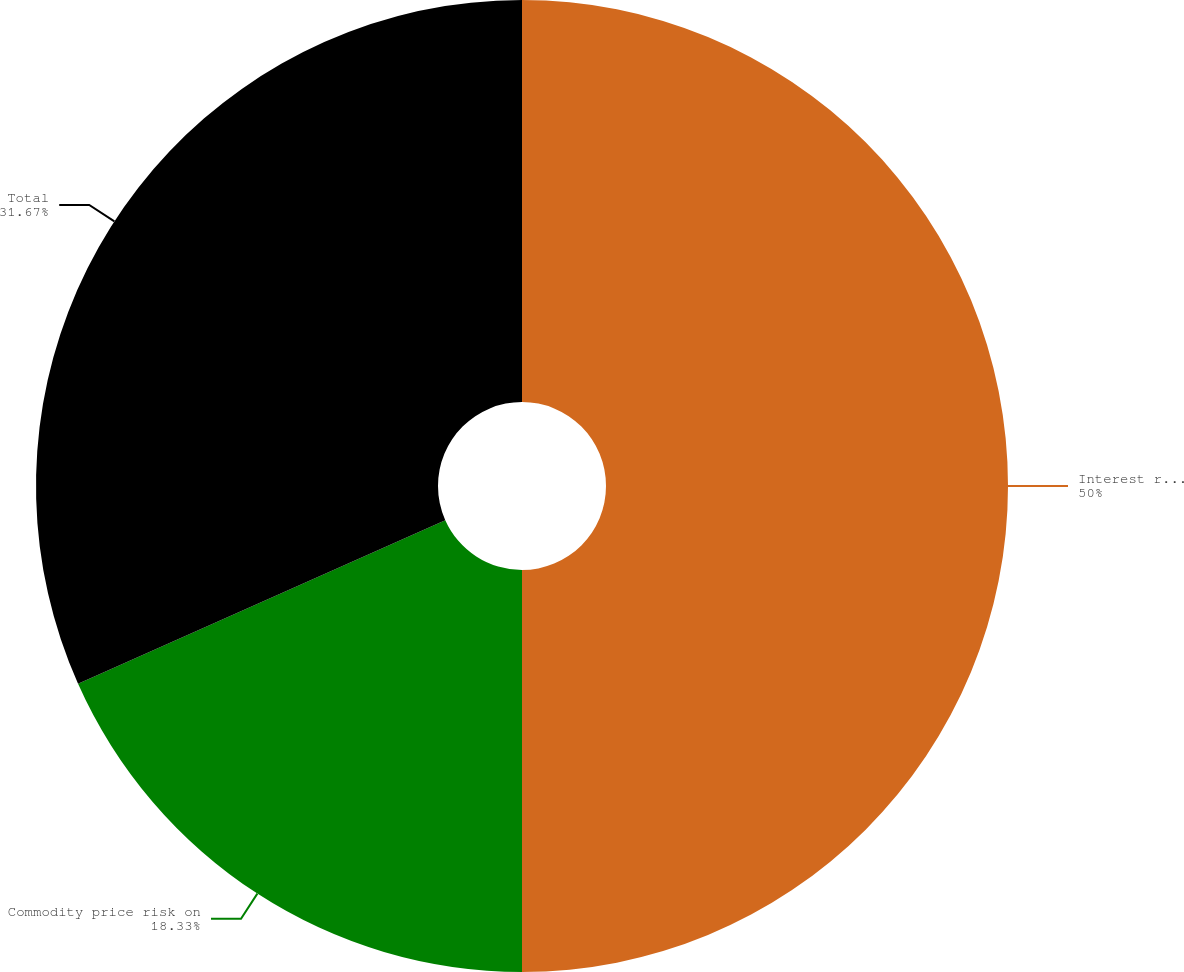Convert chart to OTSL. <chart><loc_0><loc_0><loc_500><loc_500><pie_chart><fcel>Interest rate risk on variable<fcel>Commodity price risk on<fcel>Total<nl><fcel>50.0%<fcel>18.33%<fcel>31.67%<nl></chart> 